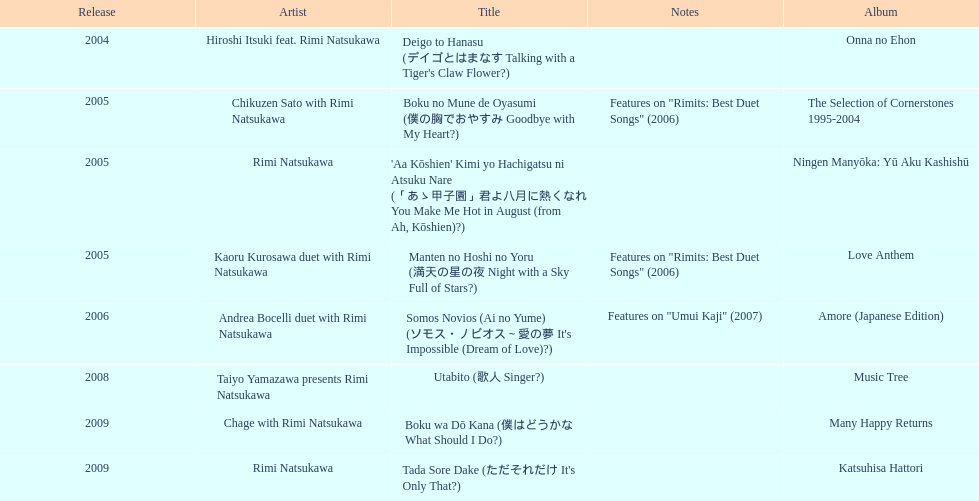In which year was the initial title launched? 2004. 